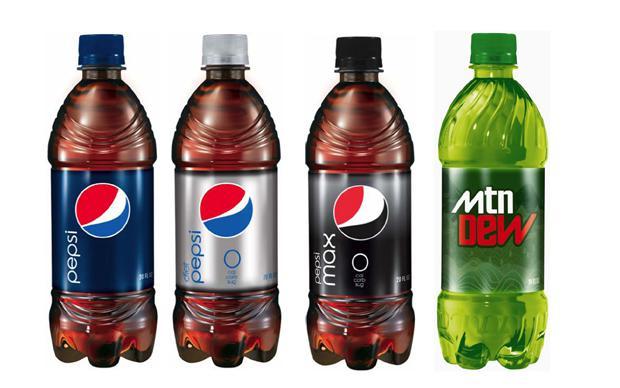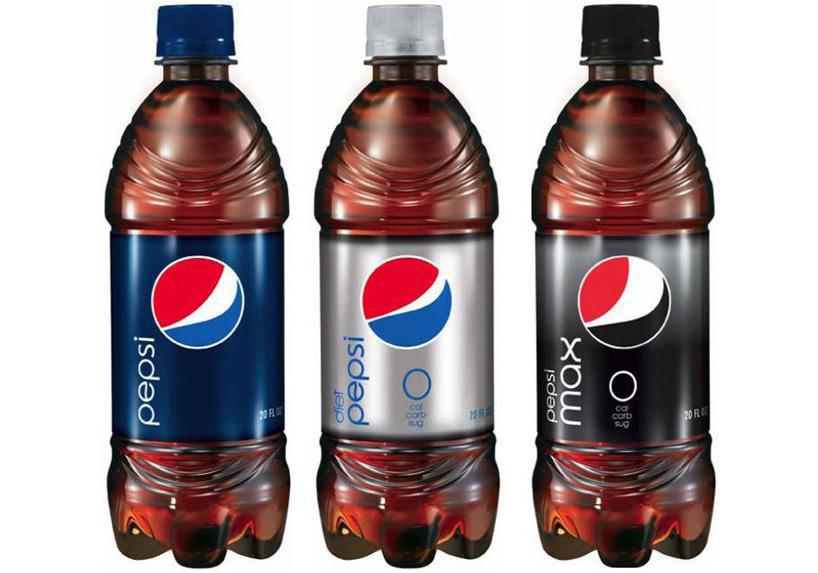The first image is the image on the left, the second image is the image on the right. Considering the images on both sides, is "One of the images has 3 bottles, while the other one has 4." valid? Answer yes or no. Yes. The first image is the image on the left, the second image is the image on the right. Given the left and right images, does the statement "There are exactly seven bottles." hold true? Answer yes or no. Yes. 